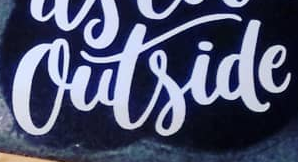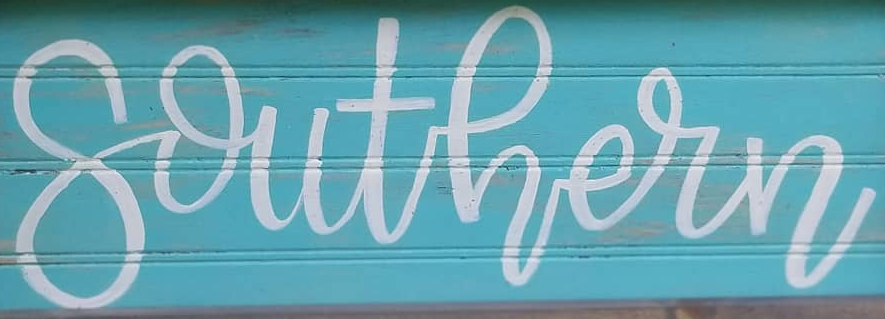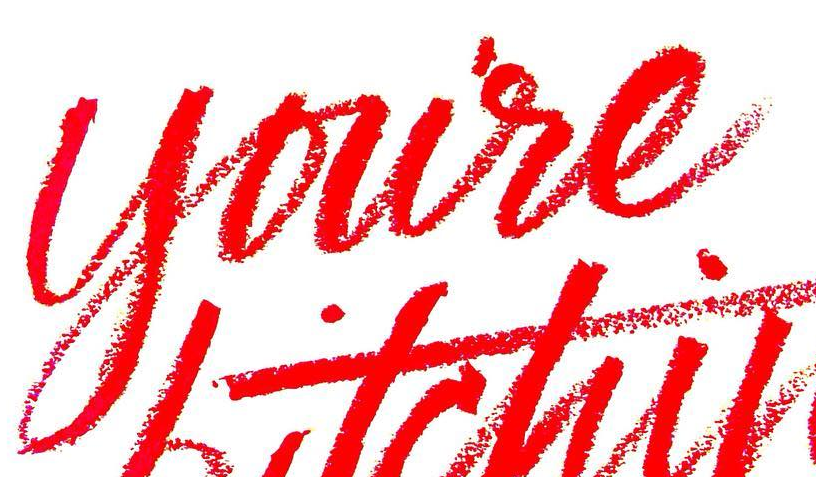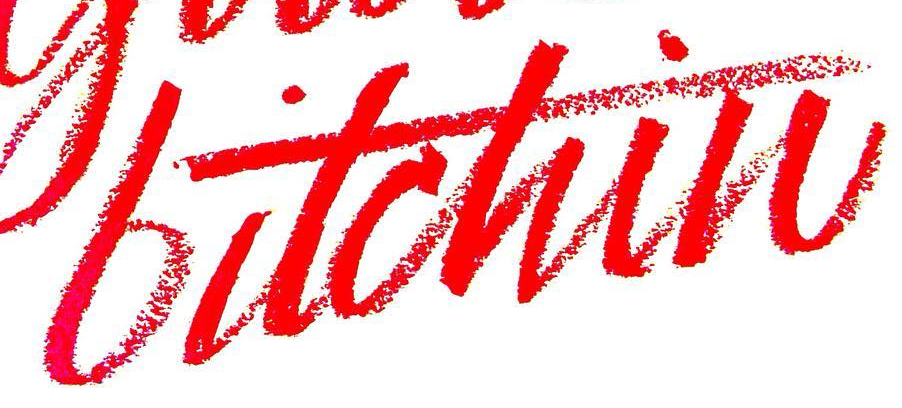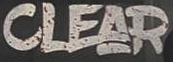What words can you see in these images in sequence, separated by a semicolon? outside; southern; youre; bitchin; CLEAR 